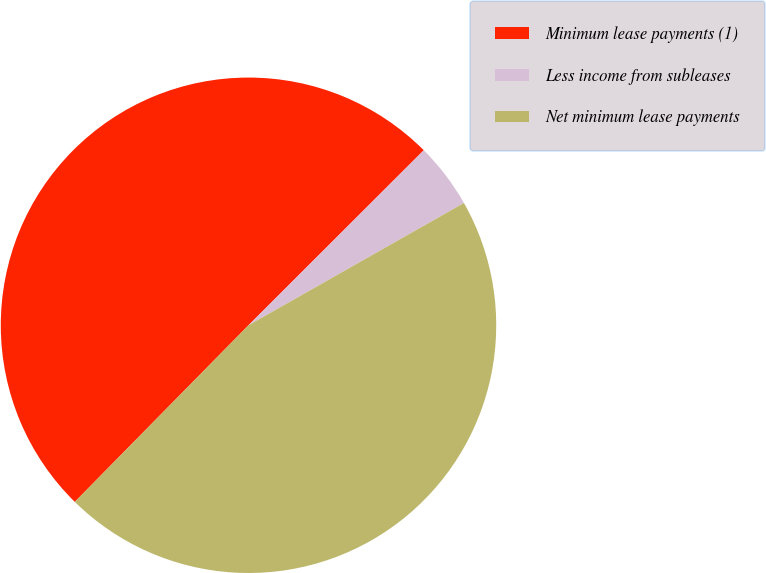Convert chart. <chart><loc_0><loc_0><loc_500><loc_500><pie_chart><fcel>Minimum lease payments (1)<fcel>Less income from subleases<fcel>Net minimum lease payments<nl><fcel>50.15%<fcel>4.27%<fcel>45.59%<nl></chart> 